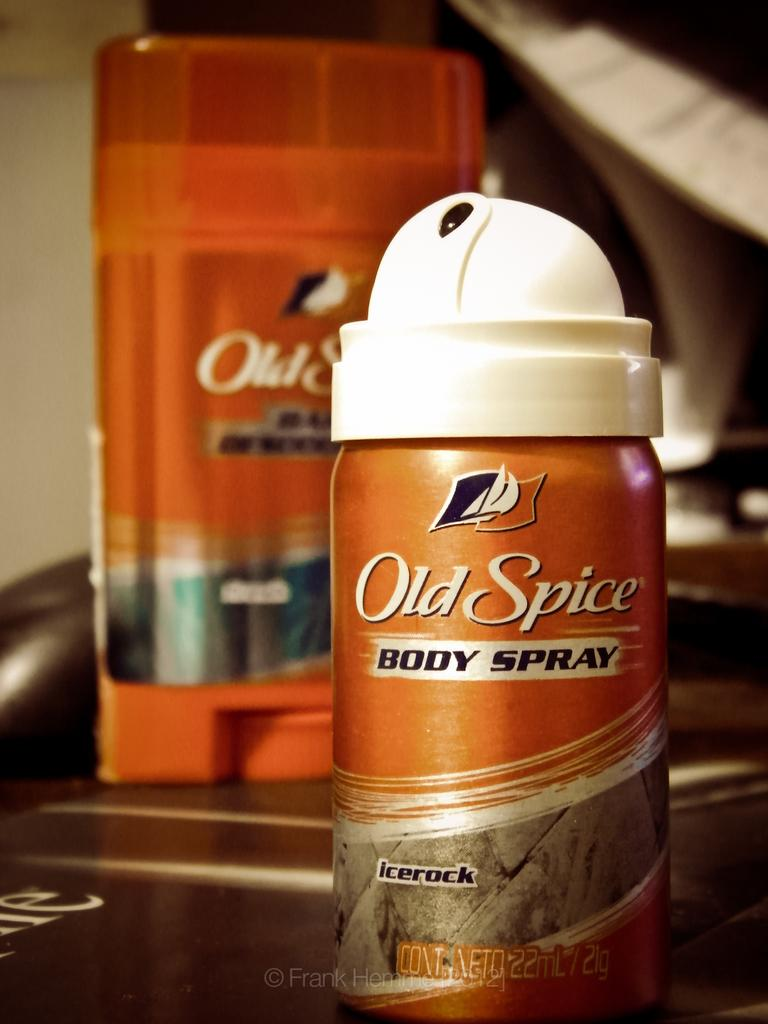<image>
Render a clear and concise summary of the photo. the word old spice that is on some can 